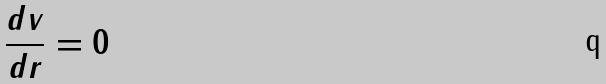Convert formula to latex. <formula><loc_0><loc_0><loc_500><loc_500>\frac { d v } { d r } = 0</formula> 